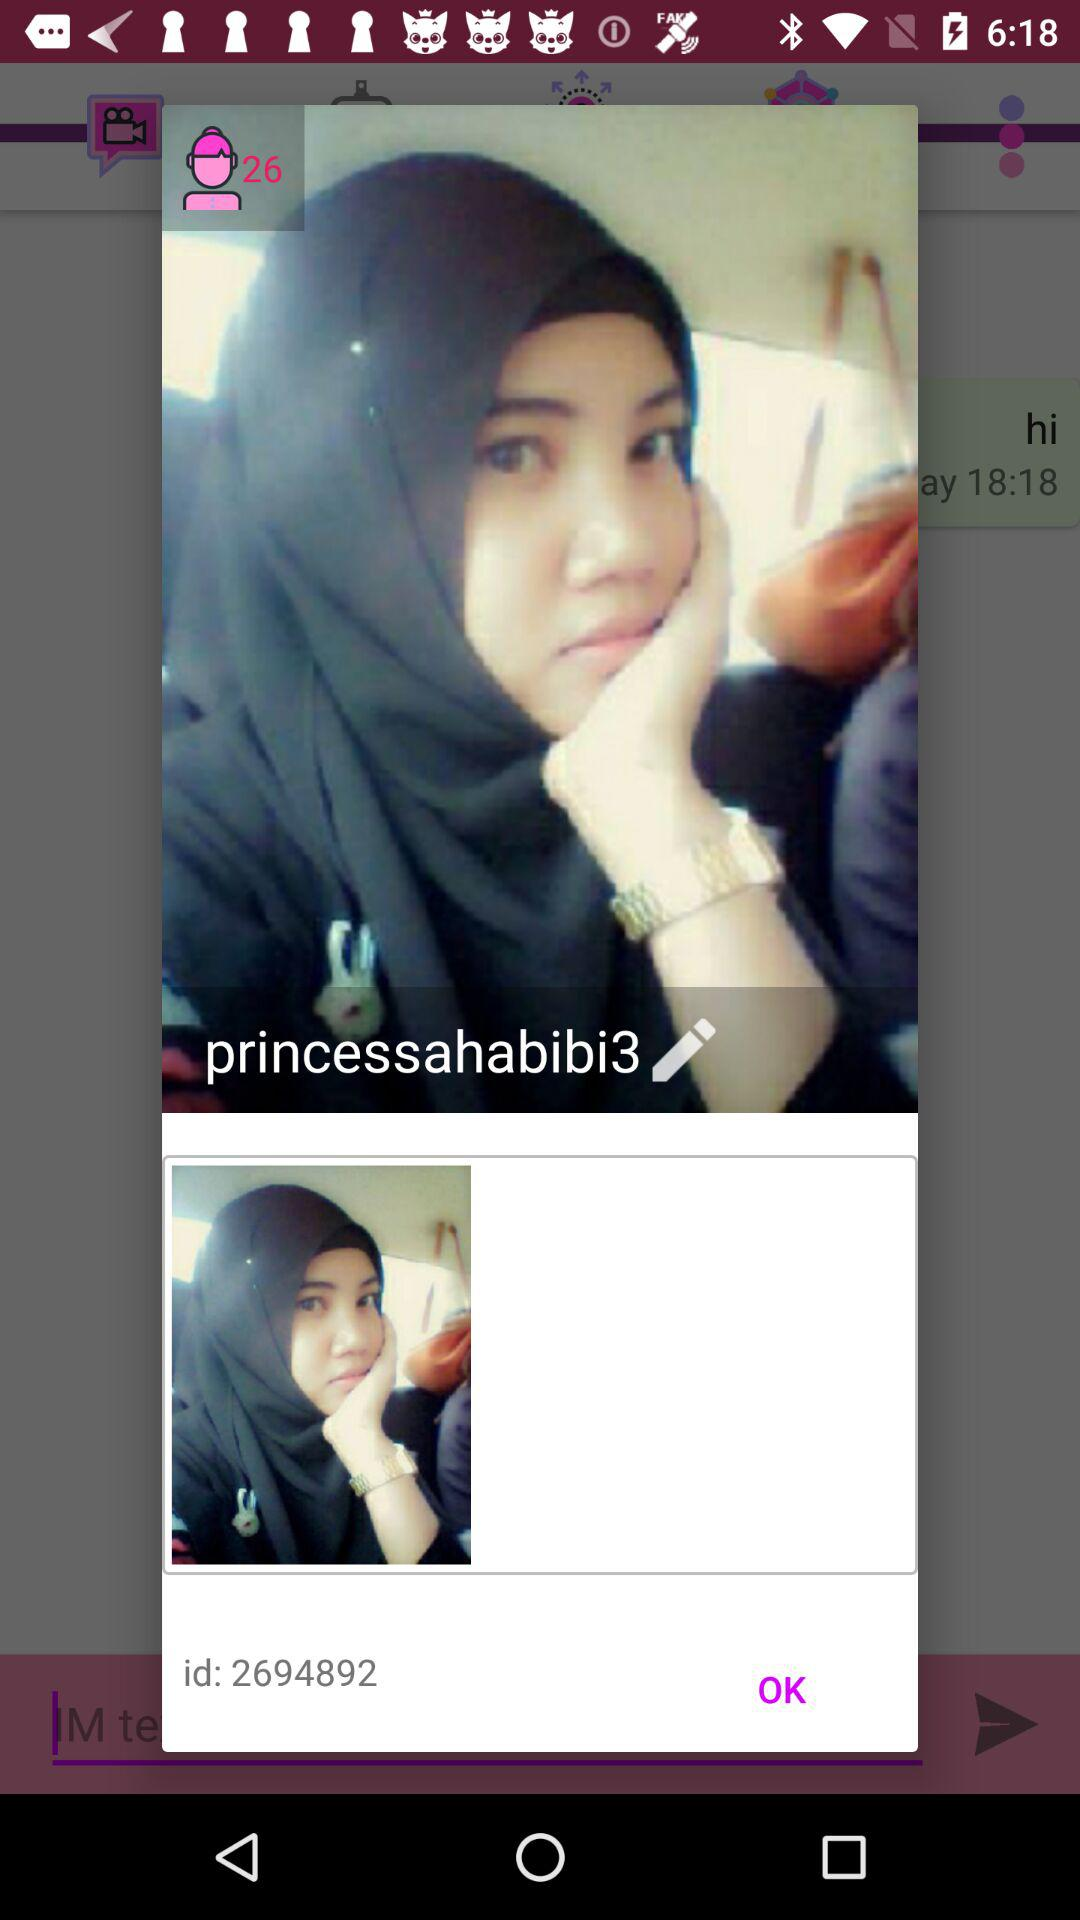What is the identification number? The identification number is 2694892. 